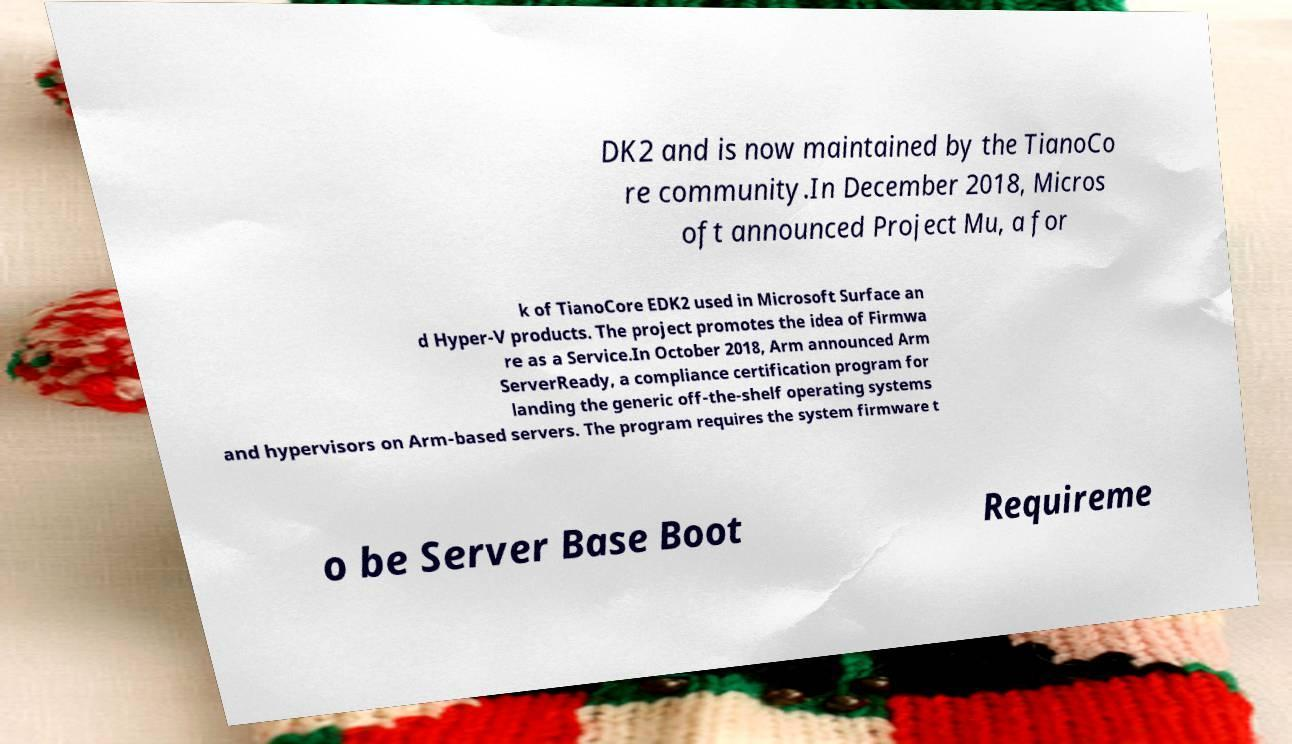Can you accurately transcribe the text from the provided image for me? DK2 and is now maintained by the TianoCo re community.In December 2018, Micros oft announced Project Mu, a for k of TianoCore EDK2 used in Microsoft Surface an d Hyper-V products. The project promotes the idea of Firmwa re as a Service.In October 2018, Arm announced Arm ServerReady, a compliance certification program for landing the generic off-the-shelf operating systems and hypervisors on Arm-based servers. The program requires the system firmware t o be Server Base Boot Requireme 